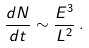Convert formula to latex. <formula><loc_0><loc_0><loc_500><loc_500>\frac { d N } { d t } \sim \frac { E ^ { 3 } } { L ^ { 2 } } \, .</formula> 